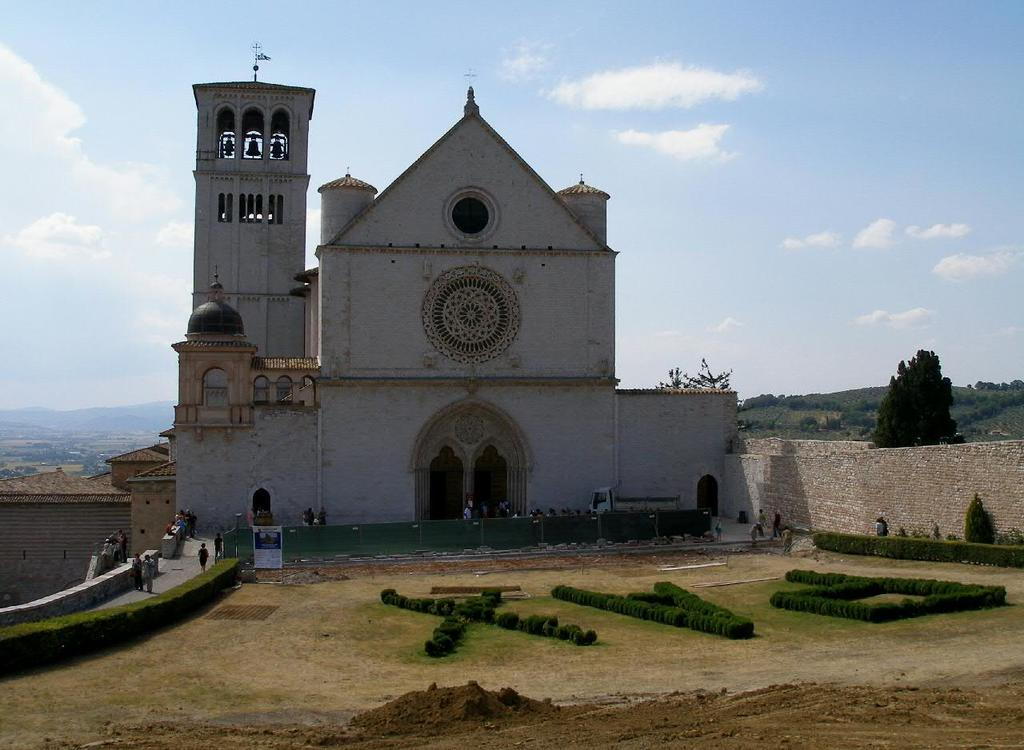What type of structure is visible in the image? There is a building in the image. What type of vegetation can be seen in the image? There is grass in the image. Are there any living beings present in the image? Yes, there are people in the image. What other natural elements can be seen in the image? There are trees in the image. What is visible in the background of the image? The sky is visible in the image, and clouds are present in the sky. What type of flower is growing on the roof of the building in the image? There is no flower growing on the roof of the building in the image. Is there a train passing by in the image? There is no train present in the image. 